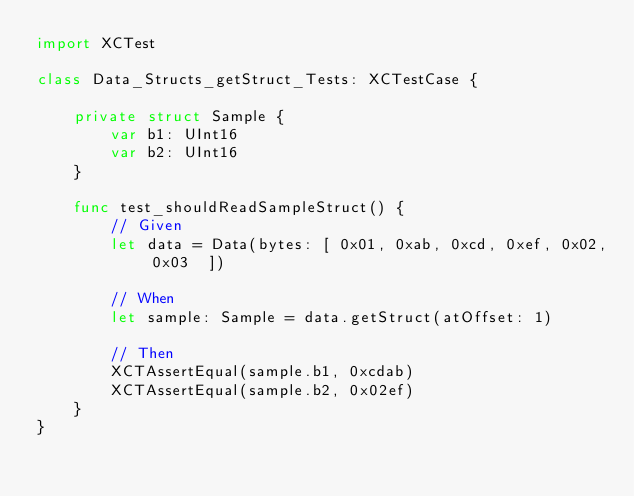Convert code to text. <code><loc_0><loc_0><loc_500><loc_500><_Swift_>import XCTest

class Data_Structs_getStruct_Tests: XCTestCase {

    private struct Sample {
        var b1: UInt16
        var b2: UInt16
    }

    func test_shouldReadSampleStruct() {
        // Given
        let data = Data(bytes: [ 0x01, 0xab, 0xcd, 0xef, 0x02, 0x03  ])

        // When
        let sample: Sample = data.getStruct(atOffset: 1)

        // Then
        XCTAssertEqual(sample.b1, 0xcdab)
        XCTAssertEqual(sample.b2, 0x02ef)
    }
}
</code> 